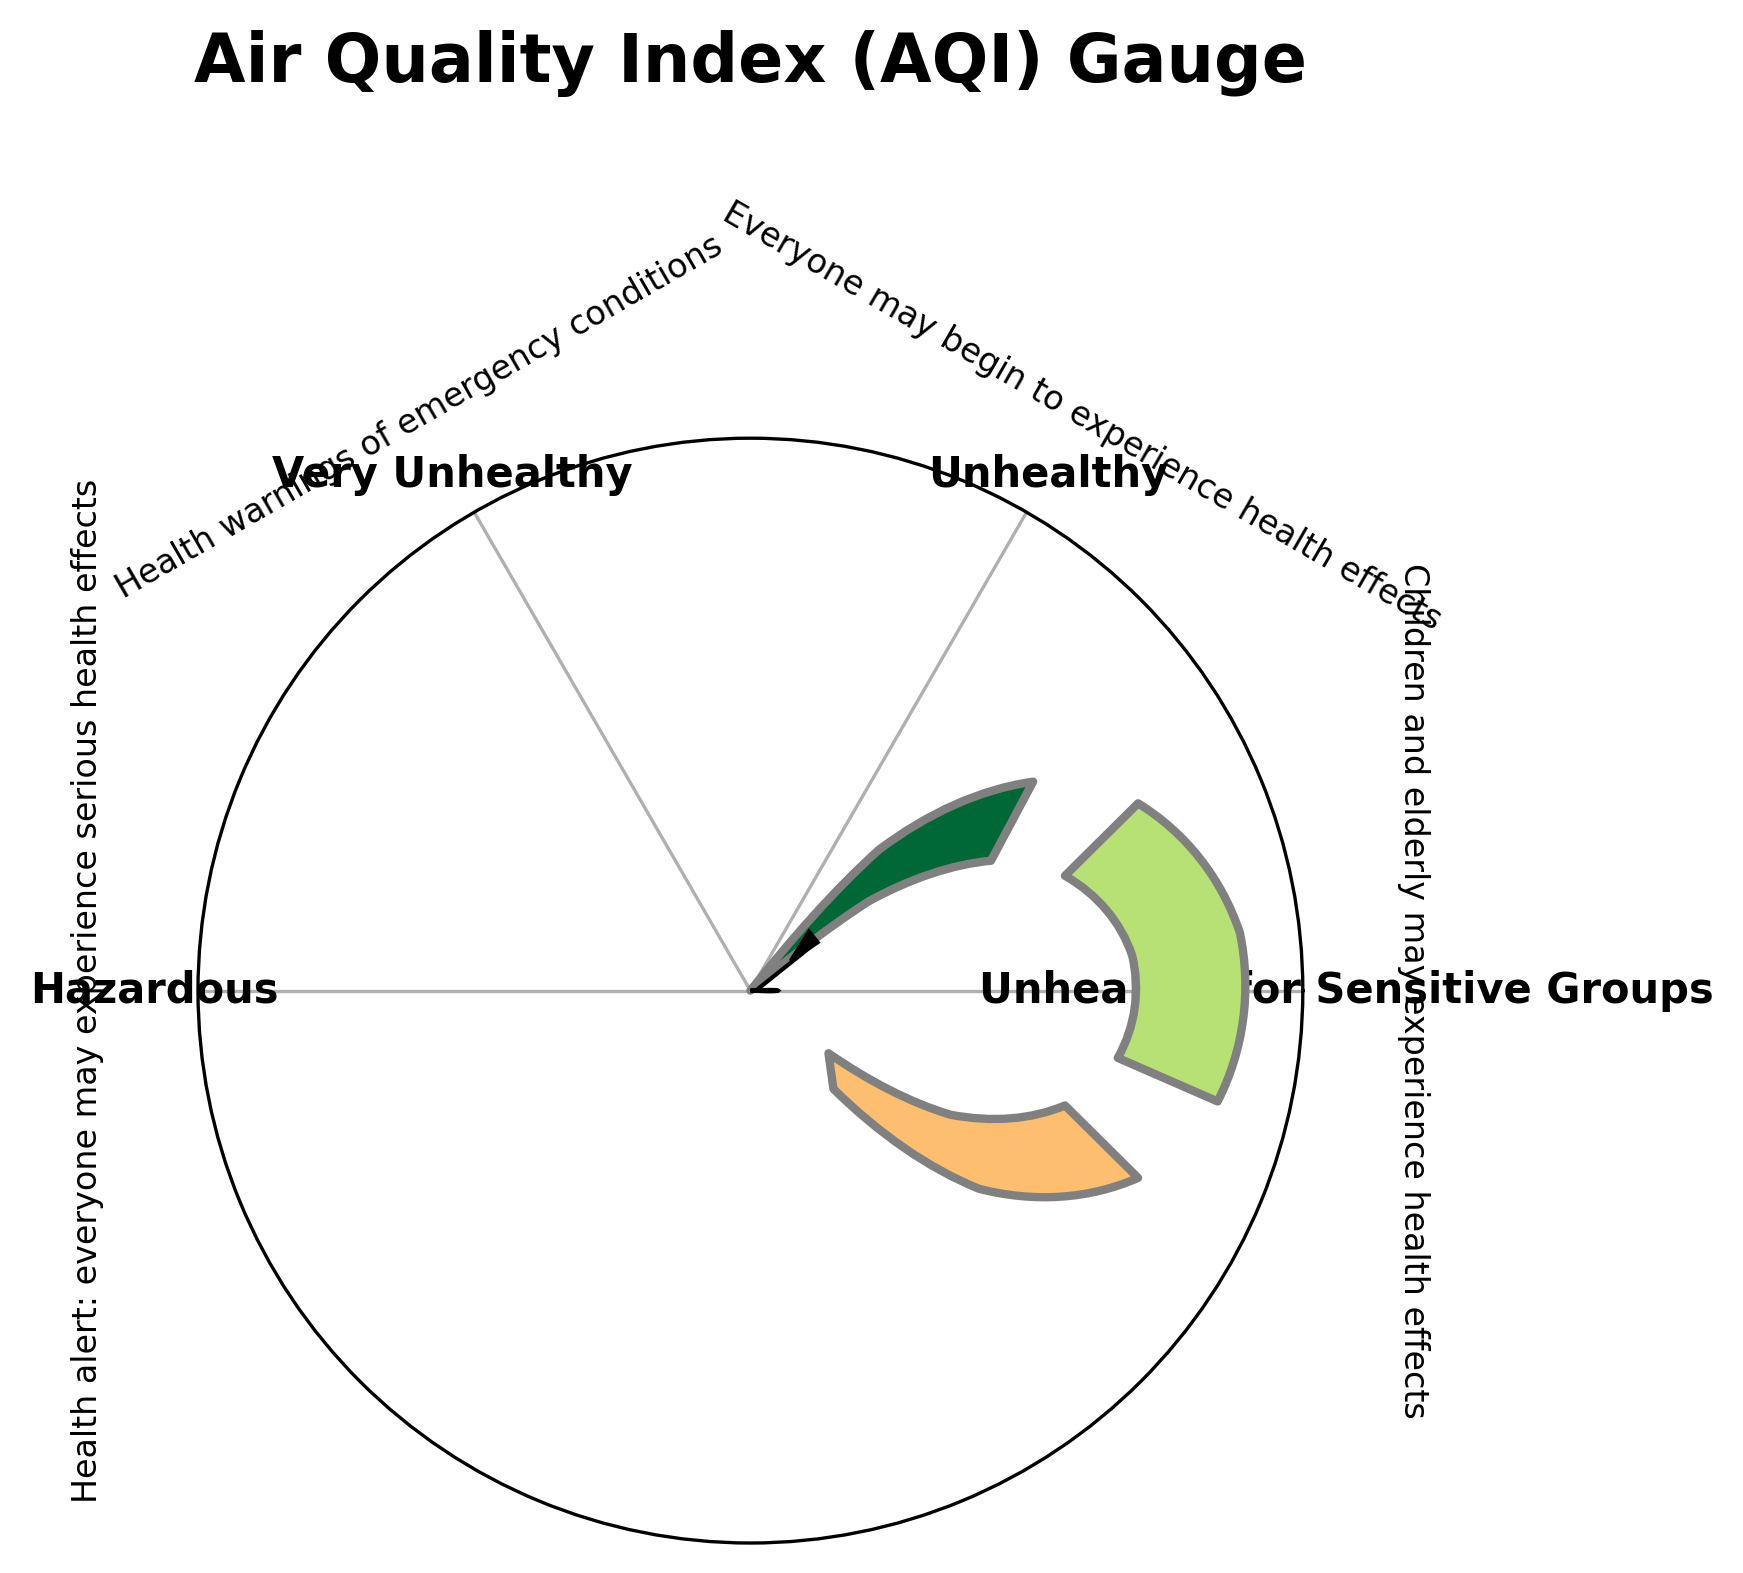What is the title of the gauge chart? The title of the gauge chart is usually displayed at the top center of the figure. In this case, it is clearly visible and reads "Air Quality Index (AQI) Gauge".
Answer: Air Quality Index (AQI) Gauge What color represents the "Unhealthy" category? The colors in the gauge chart range from green to red, indicating increasing severity. The "Unhealthy" category is typically represented by a color around the middle of this range, which is orange.
Answer: Orange What is the current AQI value? The current AQI value is marked by the position of the needle on the gauge chart. It is the numerical value closest to where the needle points. Here, it is evident that the needle indicates an AQI of 125.
Answer: 125 What does the "Hazardous" category signify for health effects? Each category in the gauge chart has an associated description for health effects. The "Hazardous" category is specifically noted with the explanation: "Health alert: everyone may experience serious health effects."
Answer: Health alert: everyone may experience serious health effects Which category does the current AQI value of 125 belong to? To determine this, we examine the ranges for each category. The "Unhealthy for Sensitive Groups" category covers the range from 101 to 150. Since 125 falls within this range, this is the category it belongs to.
Answer: Unhealthy for Sensitive Groups How many distinct categories are shown in the gauge chart? The gauge chart uses different colored sections to represent distinct AQI severity categories. Examining these, we see there are four distinct categories.
Answer: 4 What is the range for the "Very Unhealthy" category? The ranges for each category are specified along with their labels. For "Very Unhealthy", the range is shown as 201 to 300.
Answer: 201 to 300 Which category has the widest range and what is that range? To find the widest range, we compare the numerical differences between the min and max values for each category. The "Hazardous" category ranges from 301 to 500, which is a span of 199 units, making it the widest range.
Answer: Hazardous, 301 to 500 What is the minimum value of the "Hazardous" category? The boundaries of each category are specified as min and max values. For the "Hazardous" category, the minimum value is listed as 301.
Answer: 301 If the needle pointed to 250, what health effects would be noted? If the needle pointed to 250, we would refer to the "Very Unhealthy" category, as 250 falls between the range of 201 and 300. The description accompanying this category states: "Health warnings of emergency conditions."
Answer: Health warnings of emergency conditions 